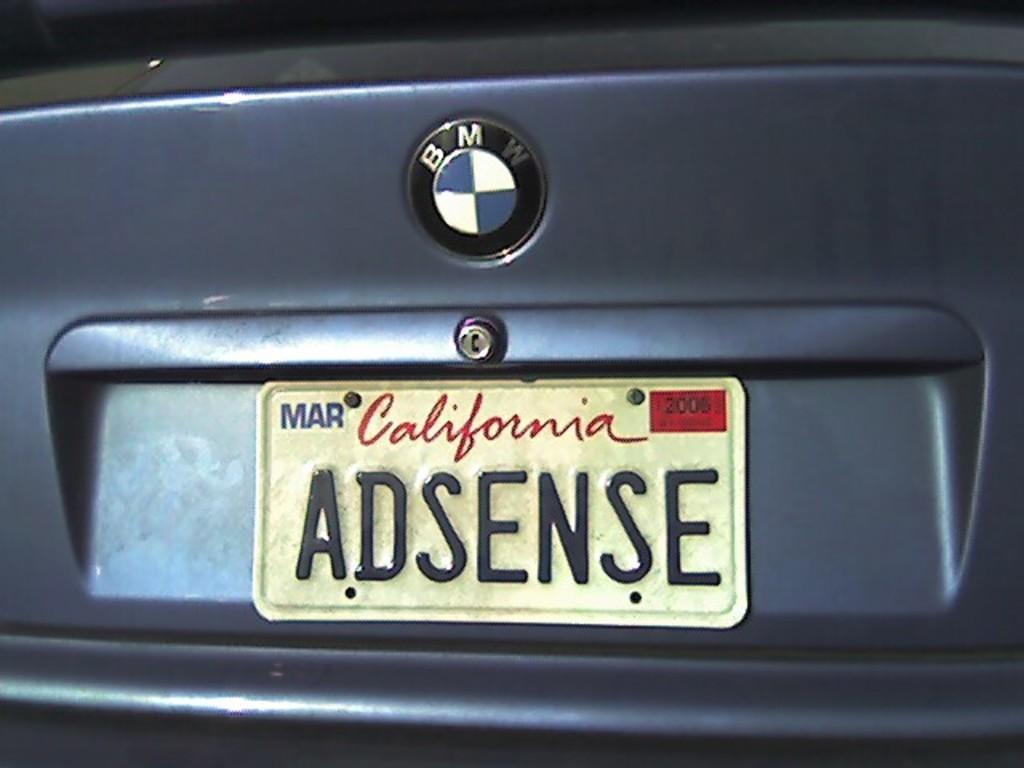Provide a one-sentence caption for the provided image. a California license plate was adsense as the letters. 